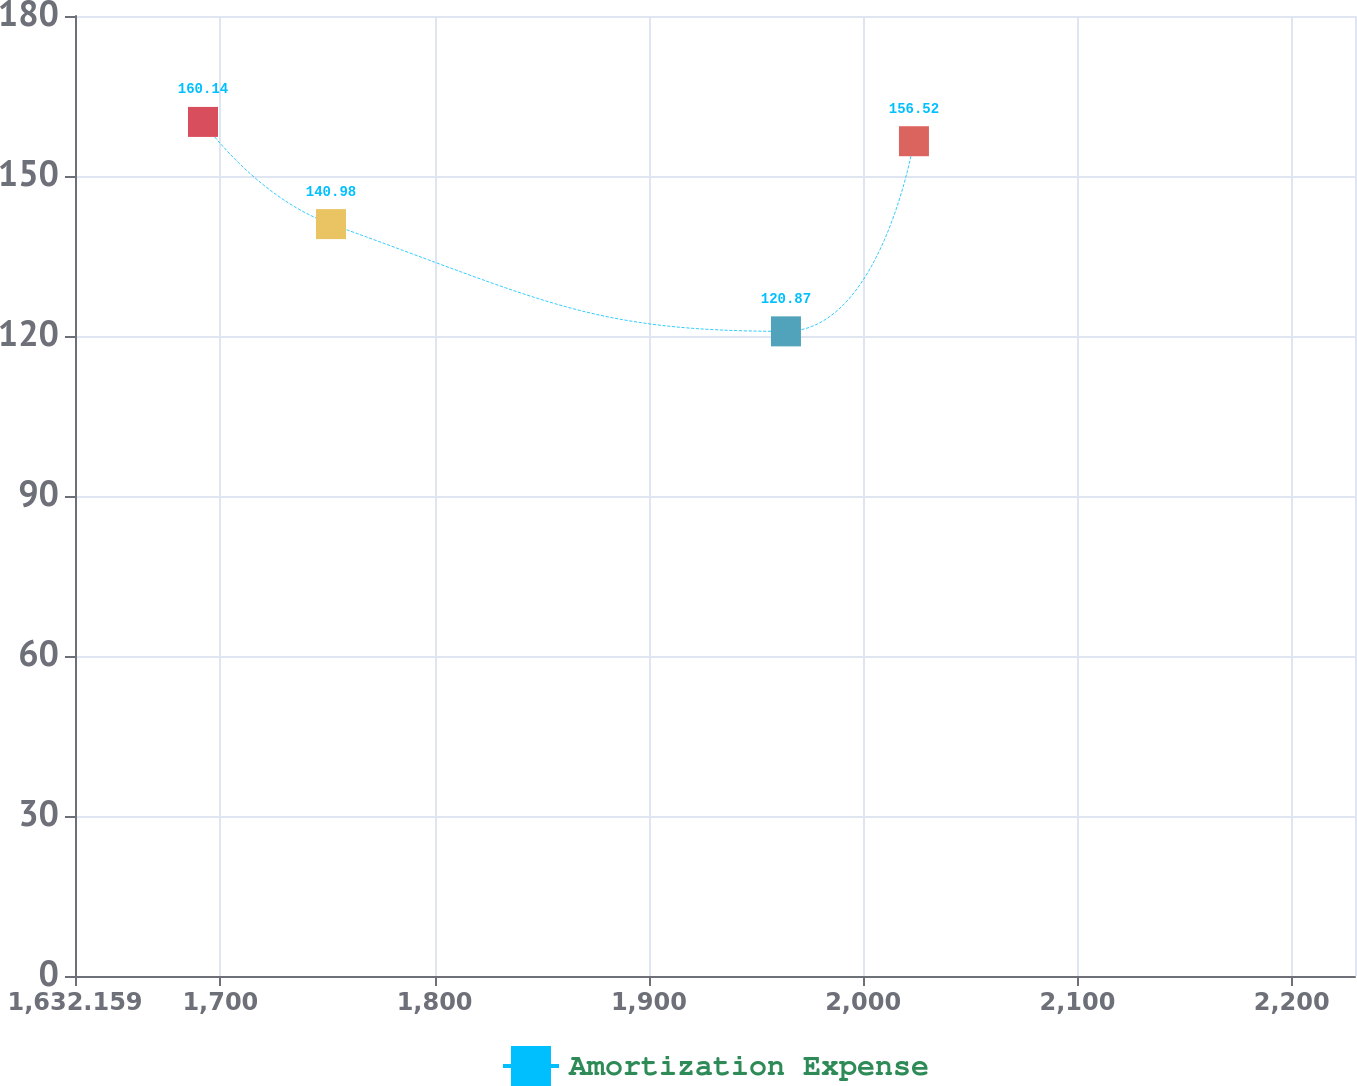Convert chart to OTSL. <chart><loc_0><loc_0><loc_500><loc_500><line_chart><ecel><fcel>Amortization Expense<nl><fcel>1691.9<fcel>160.14<nl><fcel>1751.64<fcel>140.98<nl><fcel>1963.98<fcel>120.87<nl><fcel>2023.72<fcel>156.52<nl><fcel>2289.31<fcel>125.5<nl></chart> 